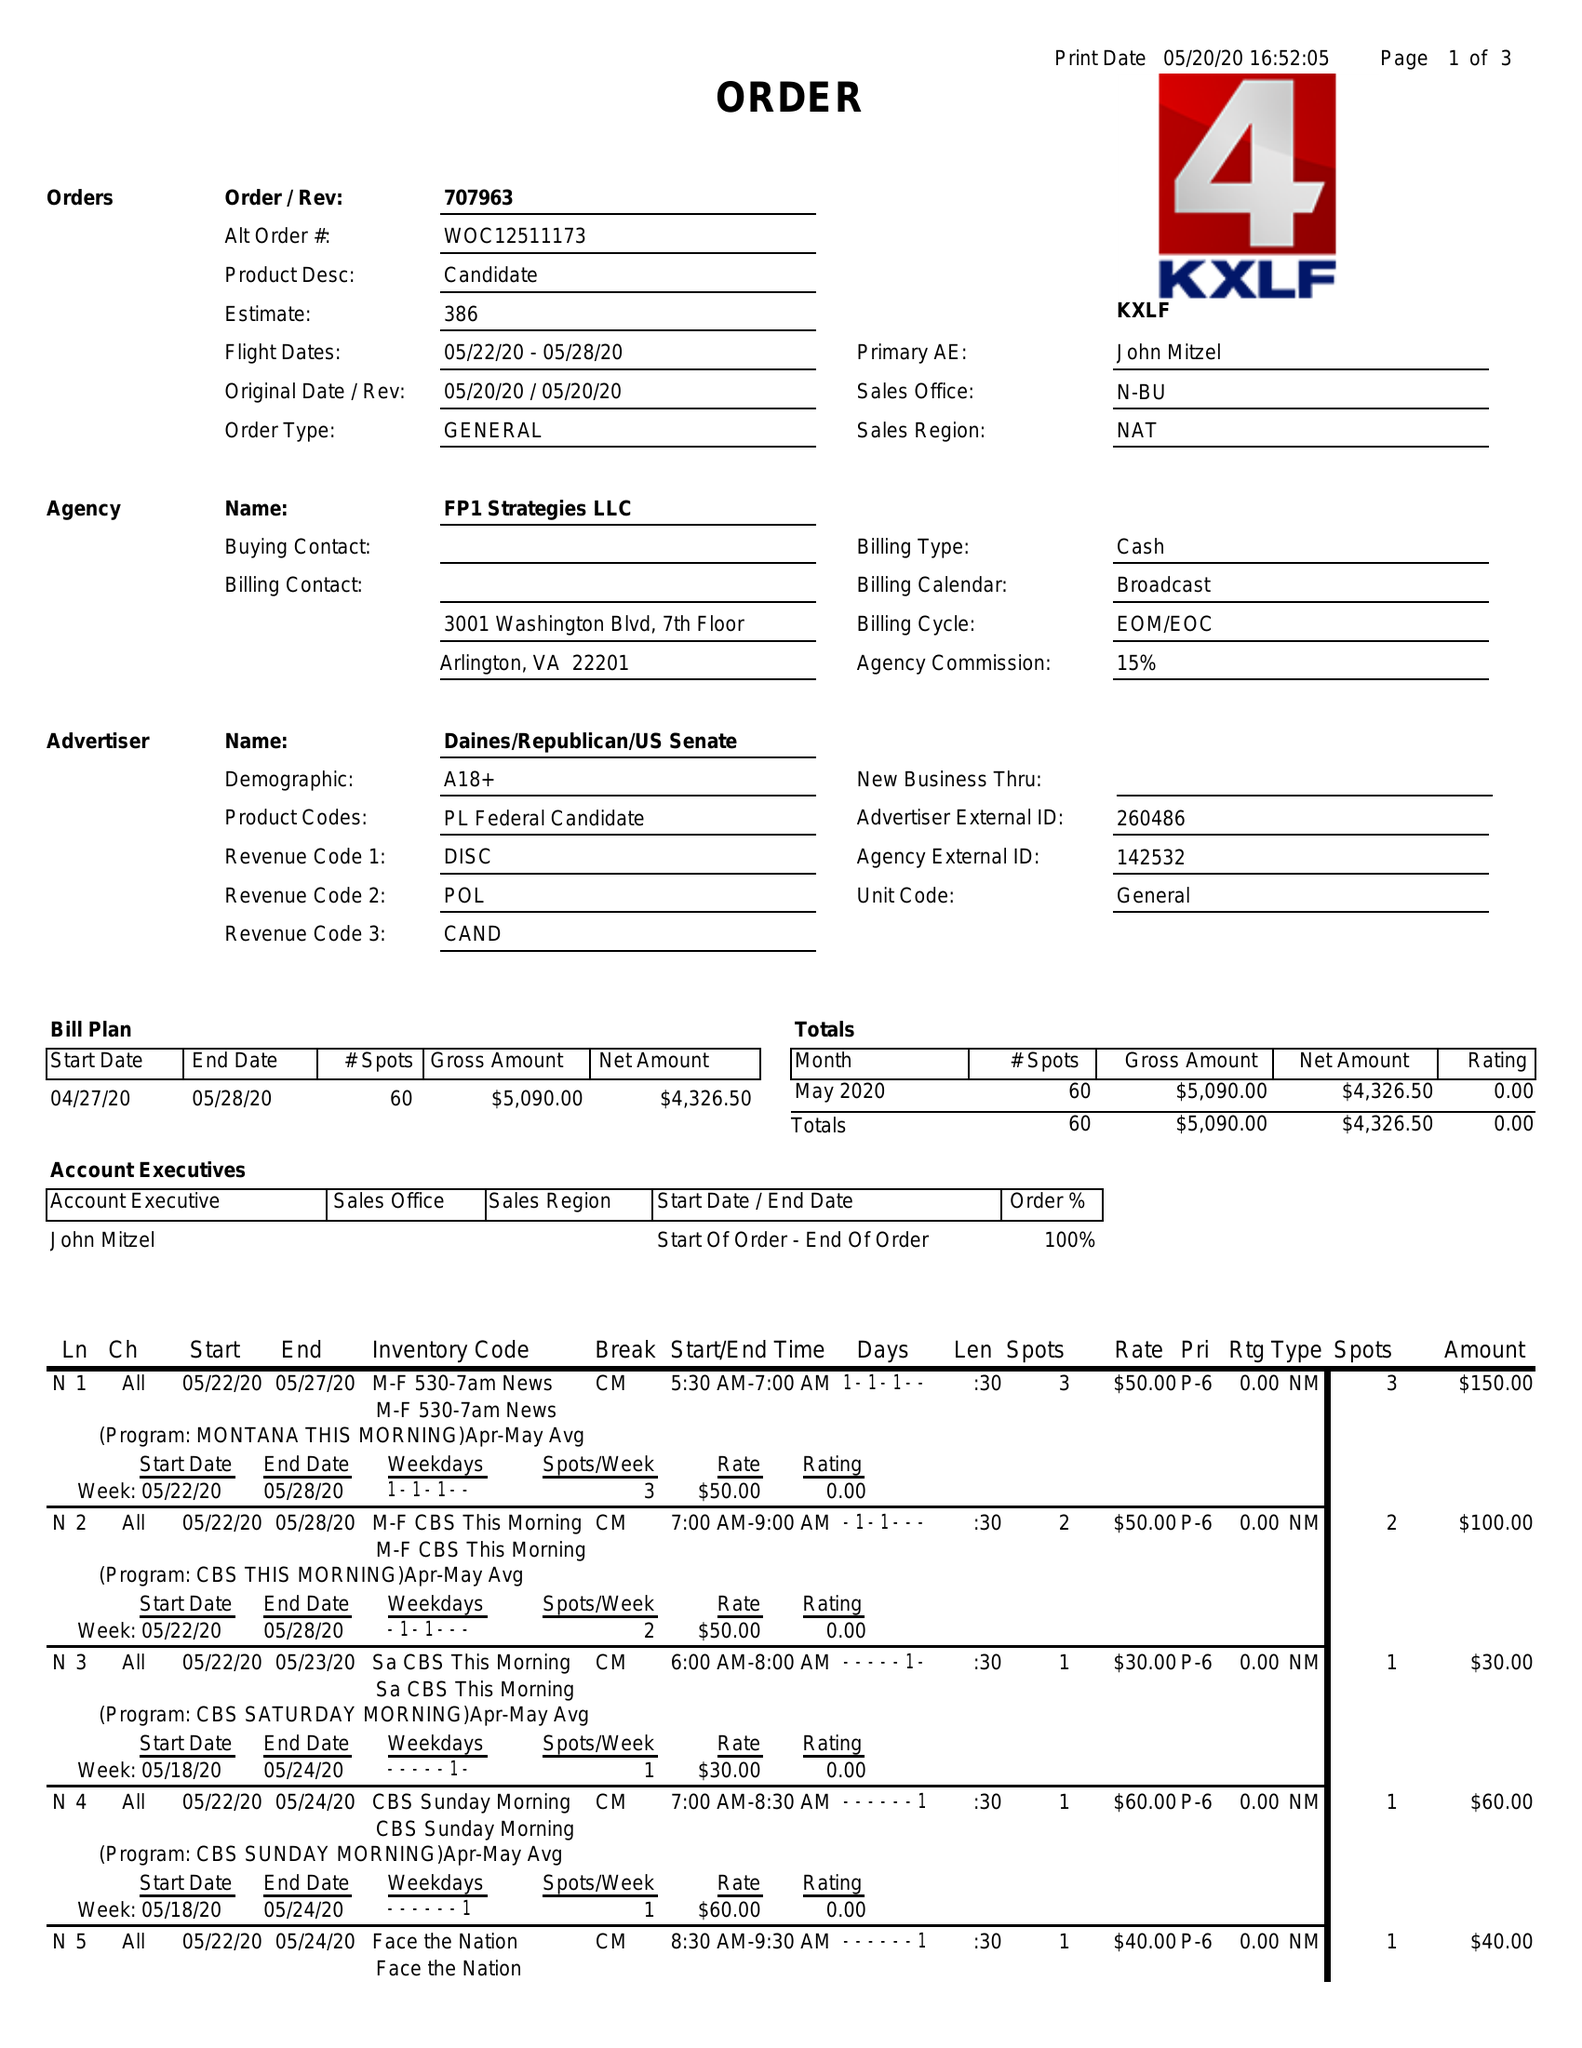What is the value for the advertiser?
Answer the question using a single word or phrase. DAINES/REPUBLICAN/USSENATE 